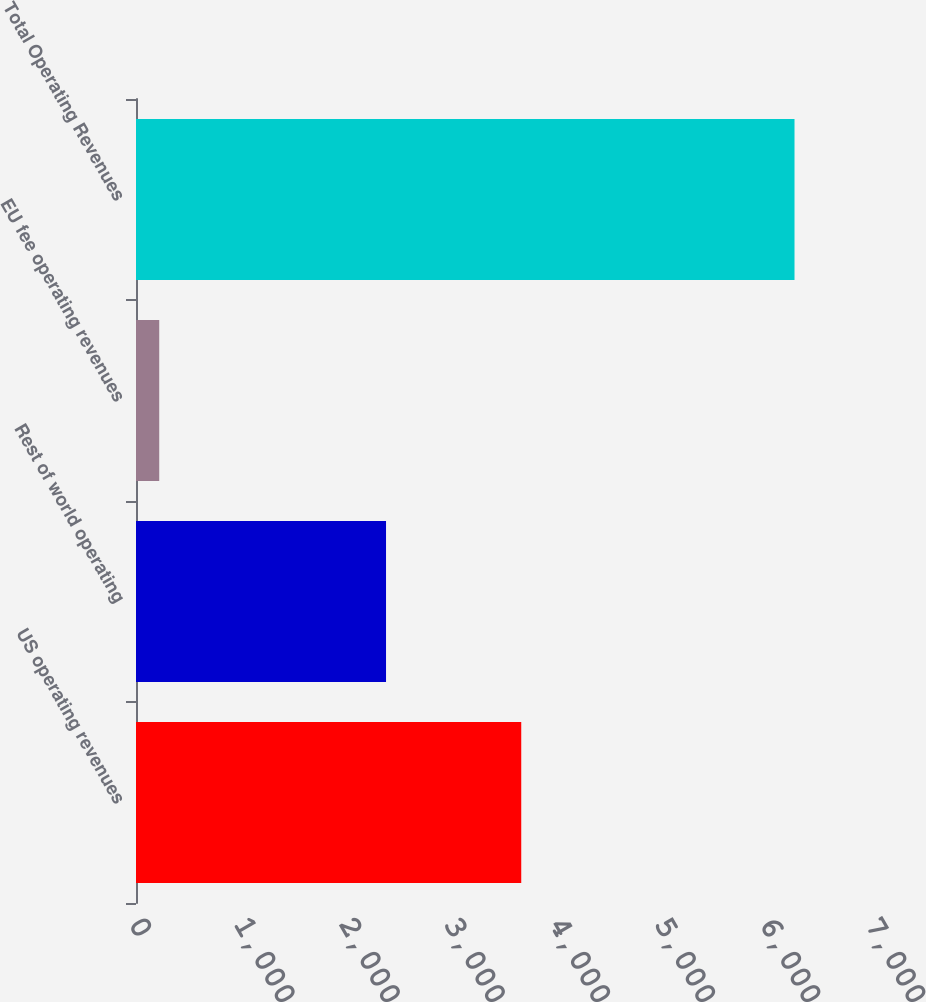Convert chart to OTSL. <chart><loc_0><loc_0><loc_500><loc_500><bar_chart><fcel>US operating revenues<fcel>Rest of world operating<fcel>EU fee operating revenues<fcel>Total Operating Revenues<nl><fcel>3664<fcel>2378<fcel>221<fcel>6263<nl></chart> 